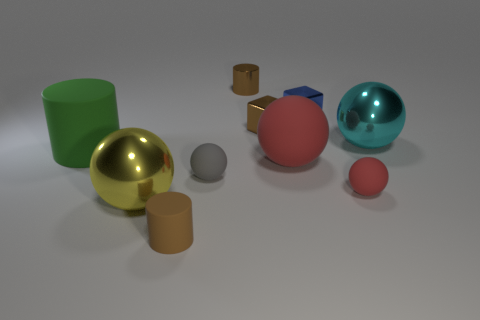Subtract 2 balls. How many balls are left? 3 Subtract all yellow balls. How many balls are left? 4 Subtract all big cyan metallic spheres. How many spheres are left? 4 Subtract all purple balls. Subtract all purple cylinders. How many balls are left? 5 Subtract all cubes. How many objects are left? 8 Subtract 1 green cylinders. How many objects are left? 9 Subtract all purple matte cylinders. Subtract all small gray spheres. How many objects are left? 9 Add 5 brown matte cylinders. How many brown matte cylinders are left? 6 Add 8 yellow shiny spheres. How many yellow shiny spheres exist? 9 